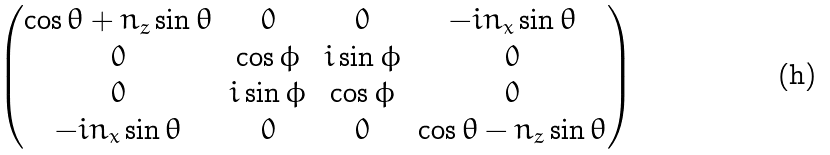Convert formula to latex. <formula><loc_0><loc_0><loc_500><loc_500>\begin{pmatrix} \cos \theta + n _ { z } \sin \theta & 0 & 0 & - i n _ { x } \sin \theta \\ 0 & \cos \phi & i \sin \phi & 0 \\ 0 & i \sin \phi & \cos \phi & 0 \\ - i n _ { x } \sin \theta & 0 & 0 & \cos \theta - n _ { z } \sin \theta \\ \end{pmatrix}</formula> 